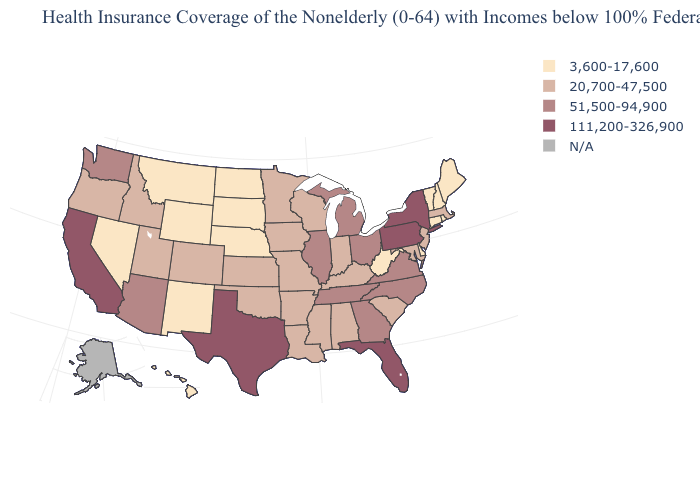How many symbols are there in the legend?
Write a very short answer. 5. How many symbols are there in the legend?
Write a very short answer. 5. What is the lowest value in states that border Tennessee?
Quick response, please. 20,700-47,500. Name the states that have a value in the range 20,700-47,500?
Keep it brief. Alabama, Arkansas, Colorado, Idaho, Indiana, Iowa, Kansas, Kentucky, Louisiana, Maryland, Massachusetts, Minnesota, Mississippi, Missouri, New Jersey, Oklahoma, Oregon, South Carolina, Utah, Wisconsin. Name the states that have a value in the range 111,200-326,900?
Quick response, please. California, Florida, New York, Pennsylvania, Texas. What is the value of Maryland?
Short answer required. 20,700-47,500. What is the lowest value in the South?
Quick response, please. 3,600-17,600. What is the highest value in the Northeast ?
Give a very brief answer. 111,200-326,900. Is the legend a continuous bar?
Keep it brief. No. Which states have the lowest value in the MidWest?
Quick response, please. Nebraska, North Dakota, South Dakota. Which states have the highest value in the USA?
Write a very short answer. California, Florida, New York, Pennsylvania, Texas. What is the value of Oklahoma?
Give a very brief answer. 20,700-47,500. Does California have the highest value in the West?
Write a very short answer. Yes. What is the value of New Hampshire?
Give a very brief answer. 3,600-17,600. Name the states that have a value in the range 51,500-94,900?
Give a very brief answer. Arizona, Georgia, Illinois, Michigan, North Carolina, Ohio, Tennessee, Virginia, Washington. 